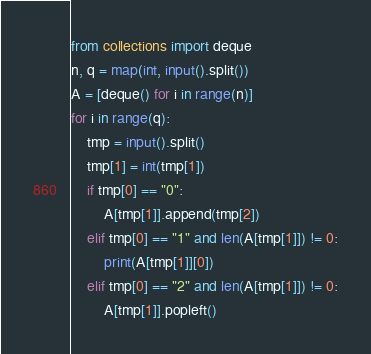<code> <loc_0><loc_0><loc_500><loc_500><_Python_>from collections import deque
n, q = map(int, input().split())
A = [deque() for i in range(n)]
for i in range(q):
    tmp = input().split()
    tmp[1] = int(tmp[1])
    if tmp[0] == "0":
        A[tmp[1]].append(tmp[2])
    elif tmp[0] == "1" and len(A[tmp[1]]) != 0:
        print(A[tmp[1]][0])
    elif tmp[0] == "2" and len(A[tmp[1]]) != 0:
        A[tmp[1]].popleft()
</code> 